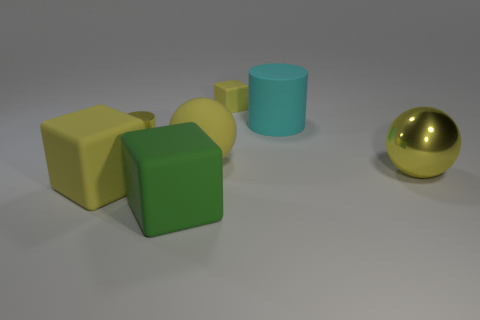Subtract all green blocks. How many blocks are left? 2 Add 2 matte cylinders. How many objects exist? 9 Subtract all yellow cylinders. How many cylinders are left? 1 Subtract 0 purple balls. How many objects are left? 7 Subtract all cylinders. How many objects are left? 5 Subtract 2 cubes. How many cubes are left? 1 Subtract all red cubes. Subtract all gray cylinders. How many cubes are left? 3 Subtract all cyan spheres. How many red cubes are left? 0 Subtract all green metal spheres. Subtract all small matte things. How many objects are left? 6 Add 7 cyan objects. How many cyan objects are left? 8 